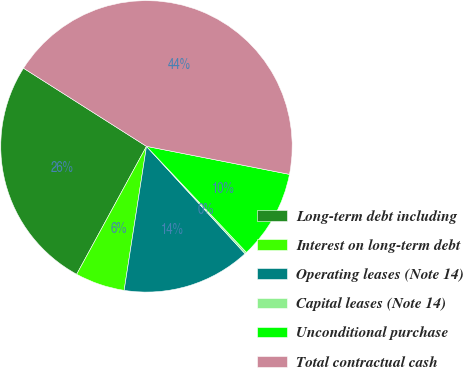Convert chart. <chart><loc_0><loc_0><loc_500><loc_500><pie_chart><fcel>Long-term debt including<fcel>Interest on long-term debt<fcel>Operating leases (Note 14)<fcel>Capital leases (Note 14)<fcel>Unconditional purchase<fcel>Total contractual cash<nl><fcel>26.06%<fcel>5.5%<fcel>14.27%<fcel>0.21%<fcel>9.89%<fcel>44.07%<nl></chart> 